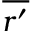<formula> <loc_0><loc_0><loc_500><loc_500>\overline { { r ^ { \prime } } }</formula> 